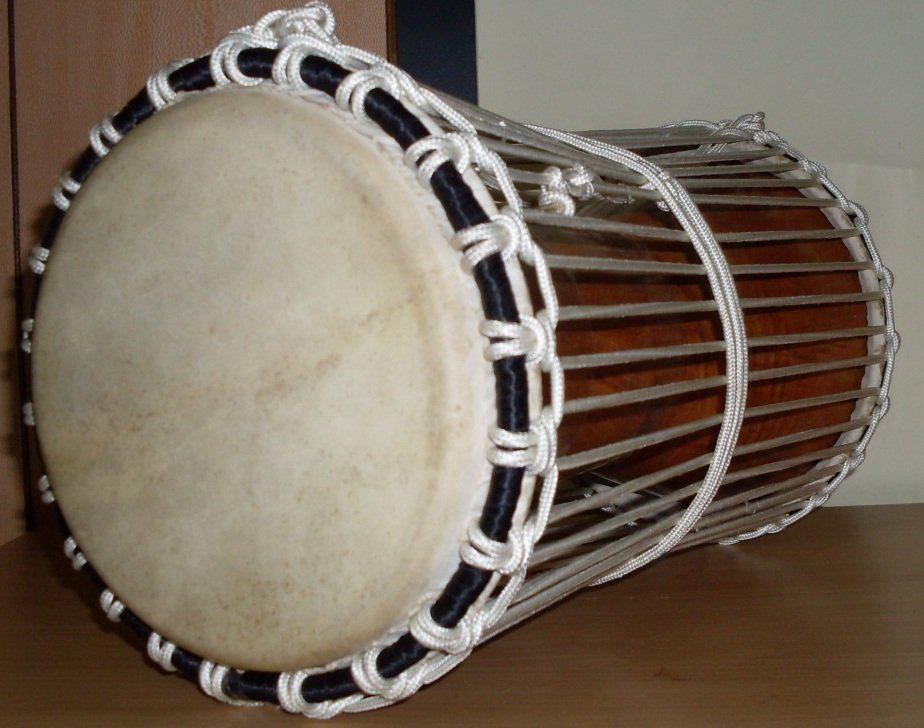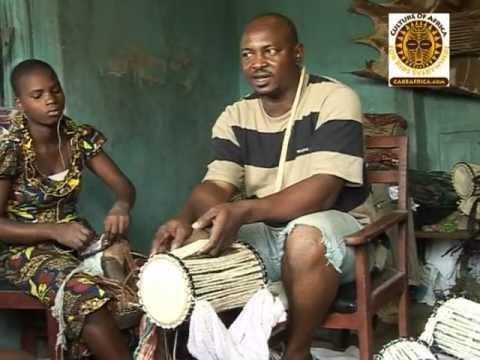The first image is the image on the left, the second image is the image on the right. Examine the images to the left and right. Is the description "The drums in each image are standing upright." accurate? Answer yes or no. No. The first image is the image on the left, the second image is the image on the right. For the images shown, is this caption "The left and right image contains the same number of drums." true? Answer yes or no. No. 